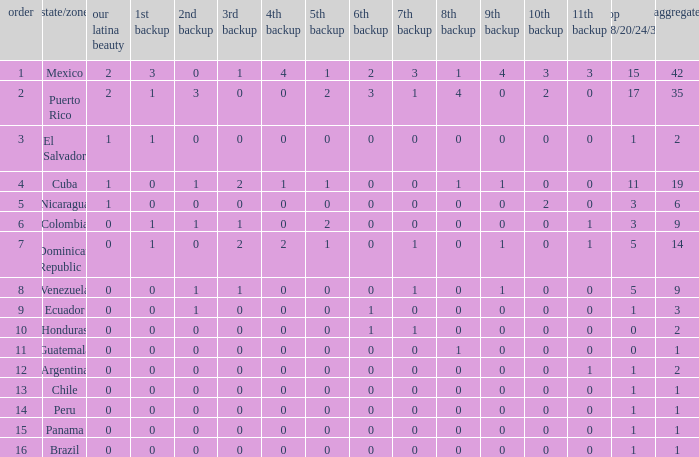What is the 3rd runner-up of the country with more than 0 9th runner-up, an 11th runner-up of 0, and the 1st runner-up greater than 0? None. 